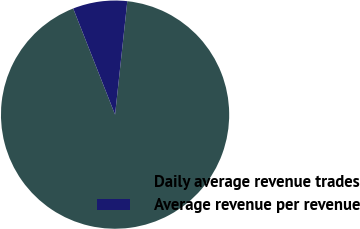Convert chart to OTSL. <chart><loc_0><loc_0><loc_500><loc_500><pie_chart><fcel>Daily average revenue trades<fcel>Average revenue per revenue<nl><fcel>92.31%<fcel>7.69%<nl></chart> 